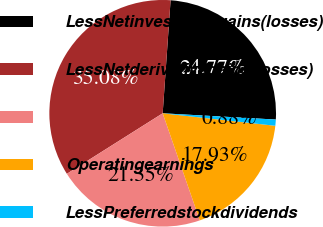Convert chart to OTSL. <chart><loc_0><loc_0><loc_500><loc_500><pie_chart><fcel>LessNetinvestmentgains(losses)<fcel>LessNetderivativegains(losses)<fcel>Unnamed: 2<fcel>Operatingearnings<fcel>LessPreferredstockdividends<nl><fcel>24.77%<fcel>35.08%<fcel>21.35%<fcel>17.93%<fcel>0.88%<nl></chart> 